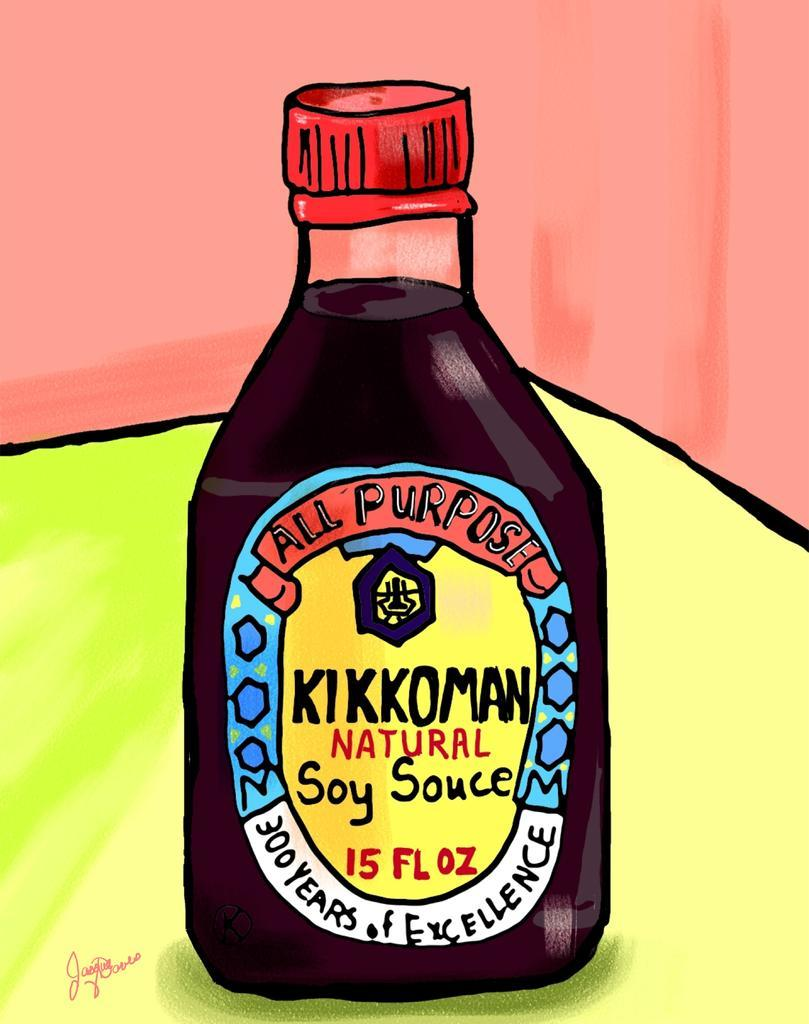<image>
Give a short and clear explanation of the subsequent image. A cartoon image of Kikkoman Natural Soy Sauce. 